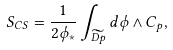<formula> <loc_0><loc_0><loc_500><loc_500>S _ { C S } = \frac { 1 } { 2 \phi _ { * } } \int _ { \widetilde { D p } } d \phi \wedge C _ { p } ,</formula> 